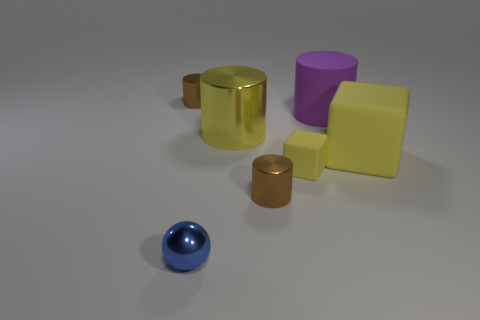Are there more big purple matte cylinders left of the blue metal ball than yellow objects that are to the left of the large purple thing?
Give a very brief answer. No. What number of cubes are small blue shiny objects or brown metal objects?
Provide a short and direct response. 0. Is there any other thing that is the same size as the purple cylinder?
Your response must be concise. Yes. Is the shape of the small object that is behind the large matte cylinder the same as  the small matte object?
Make the answer very short. No. The small rubber cube has what color?
Your answer should be compact. Yellow. There is a large rubber thing that is the same shape as the small rubber thing; what color is it?
Keep it short and to the point. Yellow. What number of yellow objects have the same shape as the purple rubber object?
Ensure brevity in your answer.  1. What number of objects are big cylinders or large purple objects that are behind the large yellow shiny thing?
Offer a very short reply. 2. There is a tiny matte thing; does it have the same color as the large object in front of the large metal thing?
Your response must be concise. Yes. There is a thing that is both behind the tiny yellow object and on the left side of the yellow cylinder; what size is it?
Provide a succinct answer. Small. 